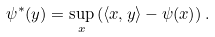<formula> <loc_0><loc_0><loc_500><loc_500>\psi ^ { * } ( y ) = \sup _ { x } \left ( \langle x , y \rangle - \psi ( x ) \right ) .</formula> 